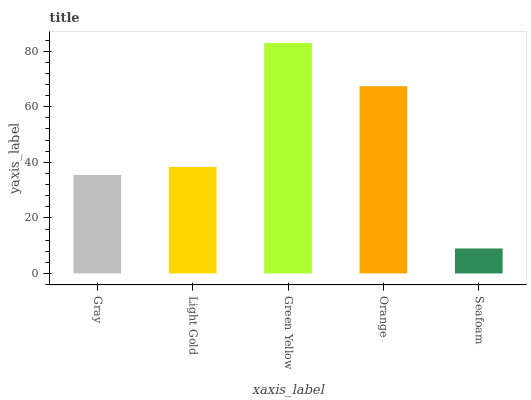Is Seafoam the minimum?
Answer yes or no. Yes. Is Green Yellow the maximum?
Answer yes or no. Yes. Is Light Gold the minimum?
Answer yes or no. No. Is Light Gold the maximum?
Answer yes or no. No. Is Light Gold greater than Gray?
Answer yes or no. Yes. Is Gray less than Light Gold?
Answer yes or no. Yes. Is Gray greater than Light Gold?
Answer yes or no. No. Is Light Gold less than Gray?
Answer yes or no. No. Is Light Gold the high median?
Answer yes or no. Yes. Is Light Gold the low median?
Answer yes or no. Yes. Is Orange the high median?
Answer yes or no. No. Is Green Yellow the low median?
Answer yes or no. No. 